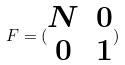<formula> <loc_0><loc_0><loc_500><loc_500>F = ( \begin{matrix} N & 0 \\ 0 & 1 \end{matrix} )</formula> 